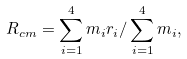<formula> <loc_0><loc_0><loc_500><loc_500>R _ { c m } = \sum _ { i = 1 } ^ { 4 } m _ { i } r _ { i } / \sum _ { i = 1 } ^ { 4 } m _ { i } ,</formula> 